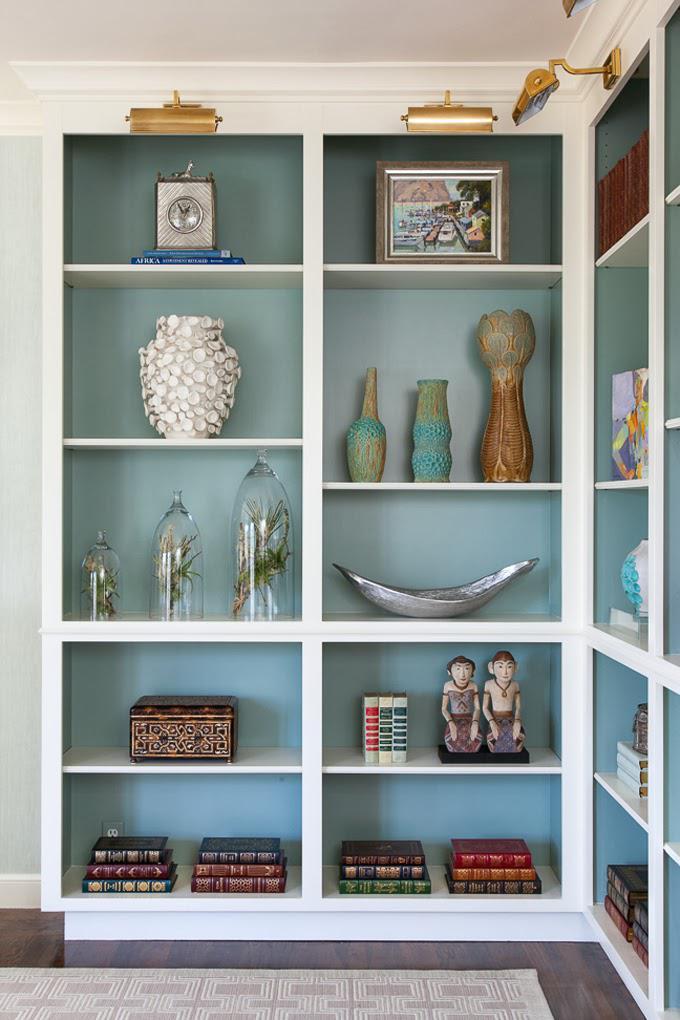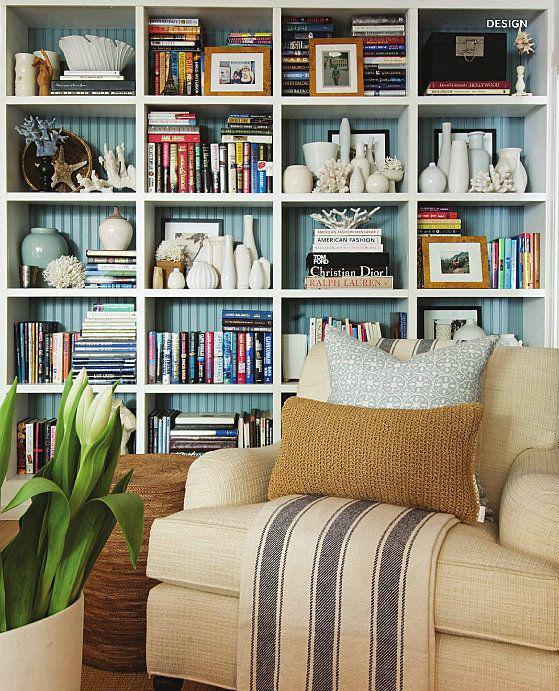The first image is the image on the left, the second image is the image on the right. For the images displayed, is the sentence "In one image, white shelving units, in a room with a sofa, chair and coffee table, have four levels of upper shelves and solid panel doors below." factually correct? Answer yes or no. No. The first image is the image on the left, the second image is the image on the right. For the images displayed, is the sentence "A plant is sitting near the furniture in the room in the image on the right." factually correct? Answer yes or no. Yes. 